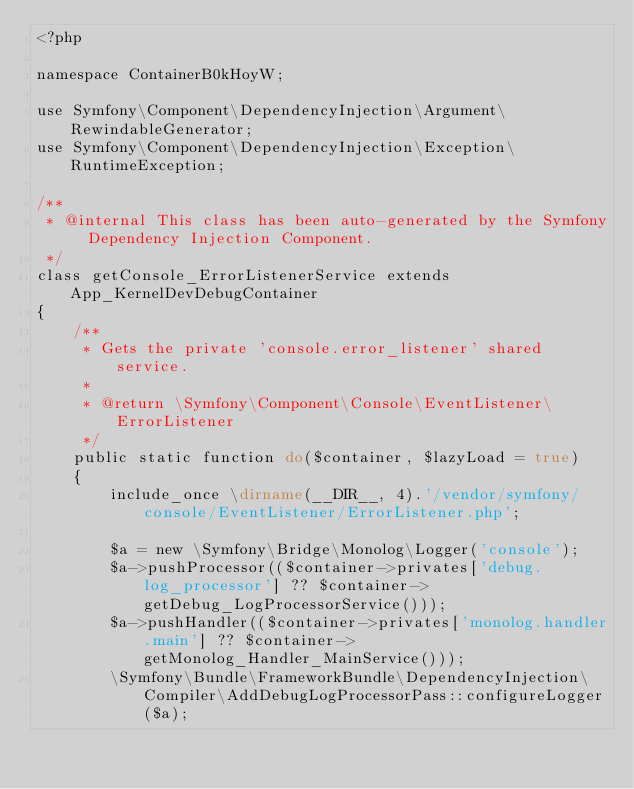Convert code to text. <code><loc_0><loc_0><loc_500><loc_500><_PHP_><?php

namespace ContainerB0kHoyW;

use Symfony\Component\DependencyInjection\Argument\RewindableGenerator;
use Symfony\Component\DependencyInjection\Exception\RuntimeException;

/**
 * @internal This class has been auto-generated by the Symfony Dependency Injection Component.
 */
class getConsole_ErrorListenerService extends App_KernelDevDebugContainer
{
    /**
     * Gets the private 'console.error_listener' shared service.
     *
     * @return \Symfony\Component\Console\EventListener\ErrorListener
     */
    public static function do($container, $lazyLoad = true)
    {
        include_once \dirname(__DIR__, 4).'/vendor/symfony/console/EventListener/ErrorListener.php';

        $a = new \Symfony\Bridge\Monolog\Logger('console');
        $a->pushProcessor(($container->privates['debug.log_processor'] ?? $container->getDebug_LogProcessorService()));
        $a->pushHandler(($container->privates['monolog.handler.main'] ?? $container->getMonolog_Handler_MainService()));
        \Symfony\Bundle\FrameworkBundle\DependencyInjection\Compiler\AddDebugLogProcessorPass::configureLogger($a);
</code> 